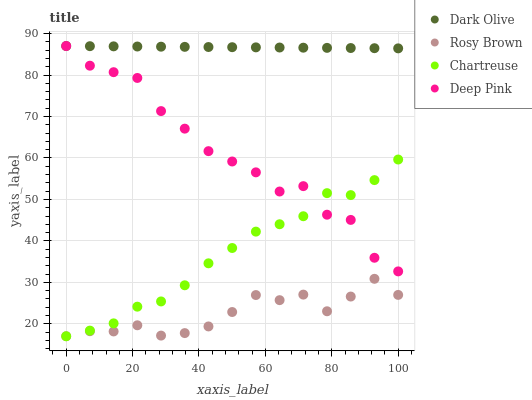Does Rosy Brown have the minimum area under the curve?
Answer yes or no. Yes. Does Dark Olive have the maximum area under the curve?
Answer yes or no. Yes. Does Chartreuse have the minimum area under the curve?
Answer yes or no. No. Does Chartreuse have the maximum area under the curve?
Answer yes or no. No. Is Dark Olive the smoothest?
Answer yes or no. Yes. Is Deep Pink the roughest?
Answer yes or no. Yes. Is Chartreuse the smoothest?
Answer yes or no. No. Is Chartreuse the roughest?
Answer yes or no. No. Does Rosy Brown have the lowest value?
Answer yes or no. Yes. Does Dark Olive have the lowest value?
Answer yes or no. No. Does Deep Pink have the highest value?
Answer yes or no. Yes. Does Chartreuse have the highest value?
Answer yes or no. No. Is Chartreuse less than Dark Olive?
Answer yes or no. Yes. Is Deep Pink greater than Rosy Brown?
Answer yes or no. Yes. Does Dark Olive intersect Deep Pink?
Answer yes or no. Yes. Is Dark Olive less than Deep Pink?
Answer yes or no. No. Is Dark Olive greater than Deep Pink?
Answer yes or no. No. Does Chartreuse intersect Dark Olive?
Answer yes or no. No. 